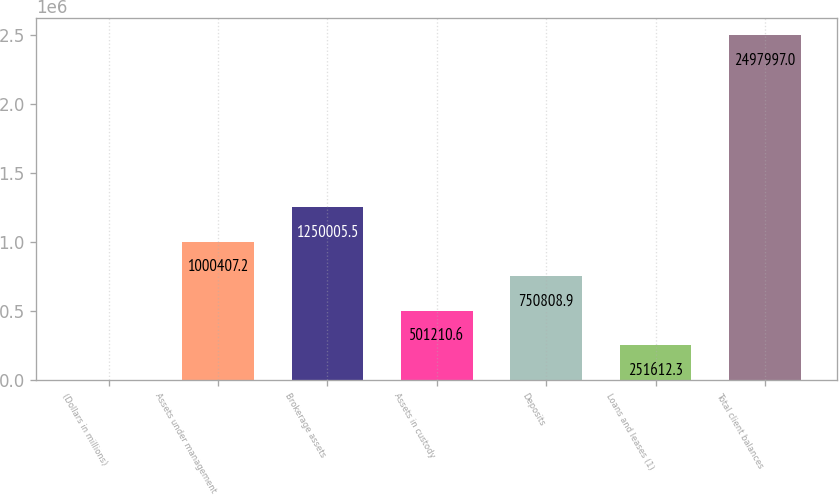<chart> <loc_0><loc_0><loc_500><loc_500><bar_chart><fcel>(Dollars in millions)<fcel>Assets under management<fcel>Brokerage assets<fcel>Assets in custody<fcel>Deposits<fcel>Loans and leases (1)<fcel>Total client balances<nl><fcel>2014<fcel>1.00041e+06<fcel>1.25001e+06<fcel>501211<fcel>750809<fcel>251612<fcel>2.498e+06<nl></chart> 